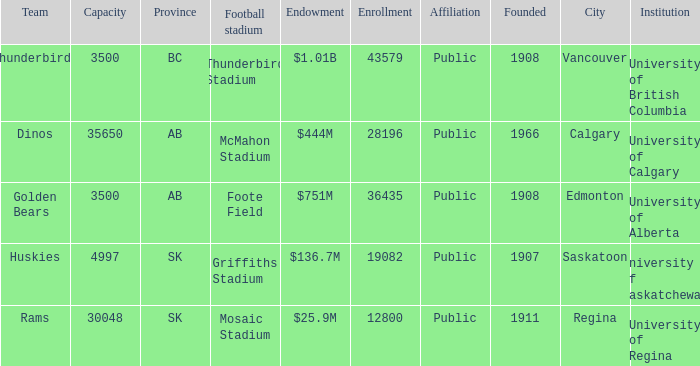Which institution has an endowment of $25.9m? University of Regina. Help me parse the entirety of this table. {'header': ['Team', 'Capacity', 'Province', 'Football stadium', 'Endowment', 'Enrollment', 'Affiliation', 'Founded', 'City', 'Institution'], 'rows': [['Thunderbirds', '3500', 'BC', 'Thunderbird Stadium', '$1.01B', '43579', 'Public', '1908', 'Vancouver', 'University of British Columbia'], ['Dinos', '35650', 'AB', 'McMahon Stadium', '$444M', '28196', 'Public', '1966', 'Calgary', 'University of Calgary'], ['Golden Bears', '3500', 'AB', 'Foote Field', '$751M', '36435', 'Public', '1908', 'Edmonton', 'University of Alberta'], ['Huskies', '4997', 'SK', 'Griffiths Stadium', '$136.7M', '19082', 'Public', '1907', 'Saskatoon', 'University of Saskatchewan'], ['Rams', '30048', 'SK', 'Mosaic Stadium', '$25.9M', '12800', 'Public', '1911', 'Regina', 'University of Regina']]} 